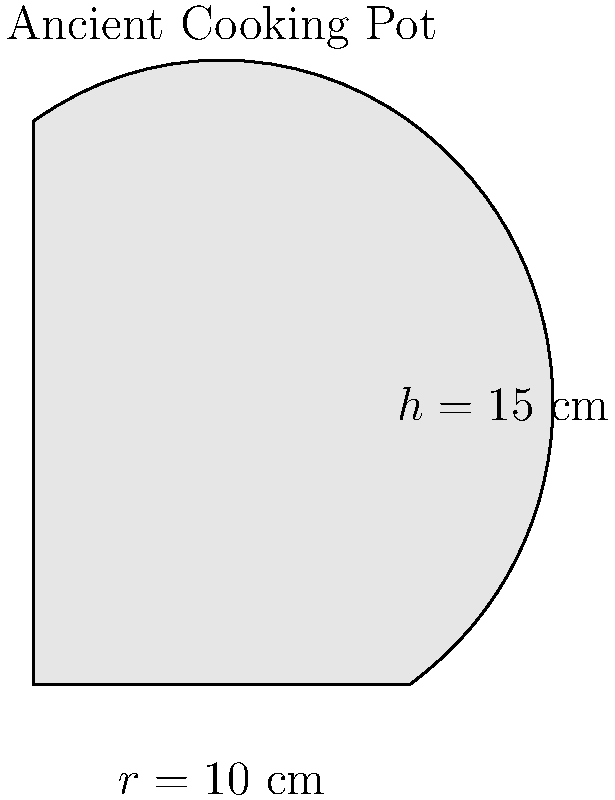An ancient cooking pot from the Roman era has been discovered during an archaeological excavation. The pot is cylindrical in shape with a radius of 10 cm and a height of 15 cm. Assuming the pot is a perfect cylinder, what is its volume in cubic centimeters (cm³)? Round your answer to the nearest whole number. To calculate the volume of a cylindrical cooking pot, we need to use the formula for the volume of a cylinder:

$$V = \pi r^2 h$$

Where:
$V$ = volume
$\pi$ = pi (approximately 3.14159)
$r$ = radius of the base
$h$ = height of the cylinder

Given:
$r = 10$ cm
$h = 15$ cm

Let's substitute these values into the formula:

$$V = \pi (10\text{ cm})^2 (15\text{ cm})$$

$$V = \pi (100\text{ cm}^2) (15\text{ cm})$$

$$V = 1500\pi\text{ cm}^3$$

Now, let's calculate this value:

$$V = 1500 \times 3.14159 \approx 4712.385\text{ cm}^3$$

Rounding to the nearest whole number:

$$V \approx 4712\text{ cm}^3$$
Answer: 4712 cm³ 